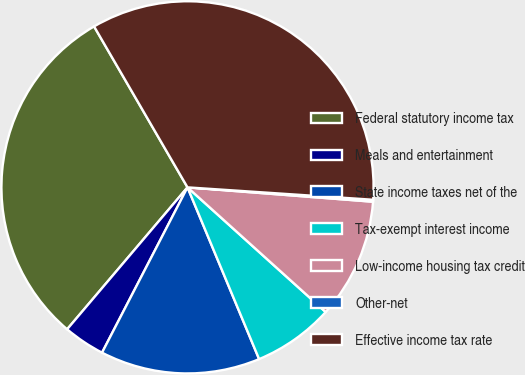<chart> <loc_0><loc_0><loc_500><loc_500><pie_chart><fcel>Federal statutory income tax<fcel>Meals and entertainment<fcel>State income taxes net of the<fcel>Tax-exempt interest income<fcel>Low-income housing tax credit<fcel>Other-net<fcel>Effective income tax rate<nl><fcel>30.43%<fcel>3.6%<fcel>13.88%<fcel>7.03%<fcel>10.45%<fcel>0.17%<fcel>34.43%<nl></chart> 